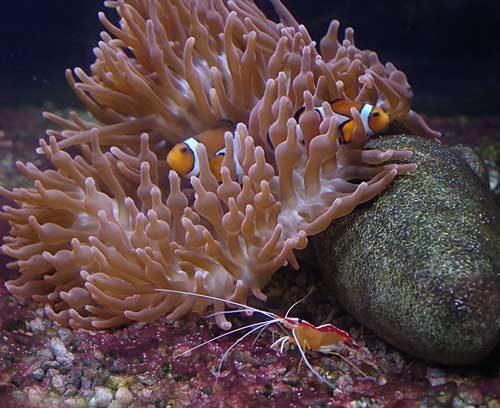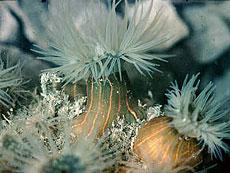The first image is the image on the left, the second image is the image on the right. Examine the images to the left and right. Is the description "One image shows a flower-look anemone with tapering tendrils around a flat center, and the other shows one large anemone with densely-packed neutral-colored tendrils." accurate? Answer yes or no. No. 